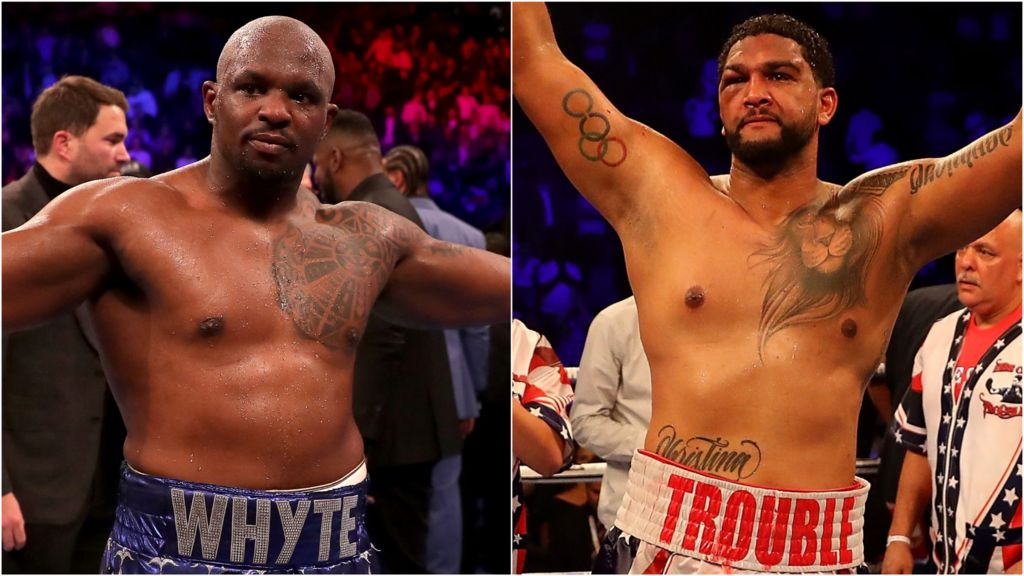If their tattoos could come to life during a match, how would they impact the fight? If their tattoos could come to life during a match, the dynamics of the fight would shift to a fantastically surreal and epic showdown. The lion tattoo on the boxer on the right might transform into a majestic, roaring lion, embodying the fierce spirit of its bearer and intimidating the opponent with its presence alone. This lion could act as a guardian, pouncing to block incoming punches or creating strategic opportunities for its master to exploit. The intricate patterns on the boxer on the left might morph into protective barriers or enhancing symbols, granting him superhuman strength and resilience. These living tattoos could also symbolize their unspoken stories and personal struggles, coming forth to boost their determination and focus in critical moments of the match. The Olympic rings could conjure memories of past glories and relentless training, fueling a surge of energy and finesse in their movements. This otherworldly scenario would add a layer of mythical excitement, depicting the fighters not just as athletes but as near-mythical heroes in a grand narrative of strength, courage, and indomitable will. 